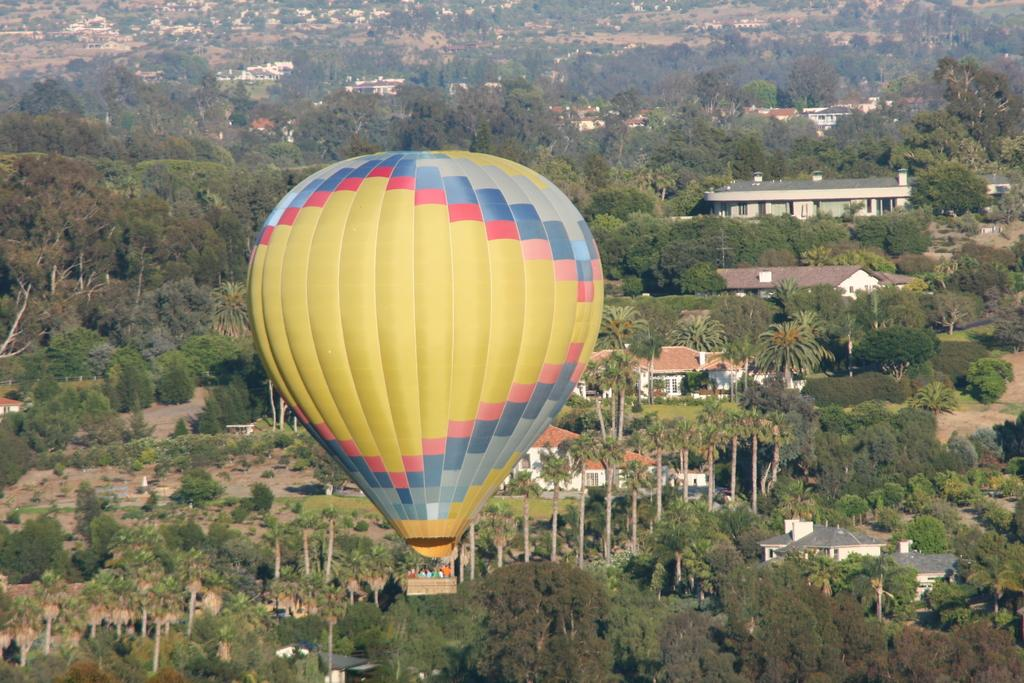What are the people in the image doing? There is a group of people in a hot air balloon in the image. What can be seen at the bottom of the image? There are buildings and trees at the bottom of the image. What is visible beneath the buildings and trees? There is ground visible in the image. What type of reward is being given to the crowd in the image? There is no crowd present in the image, and no reward is being given to them. In fact, there is no indication of any reward or crowd in the image. 